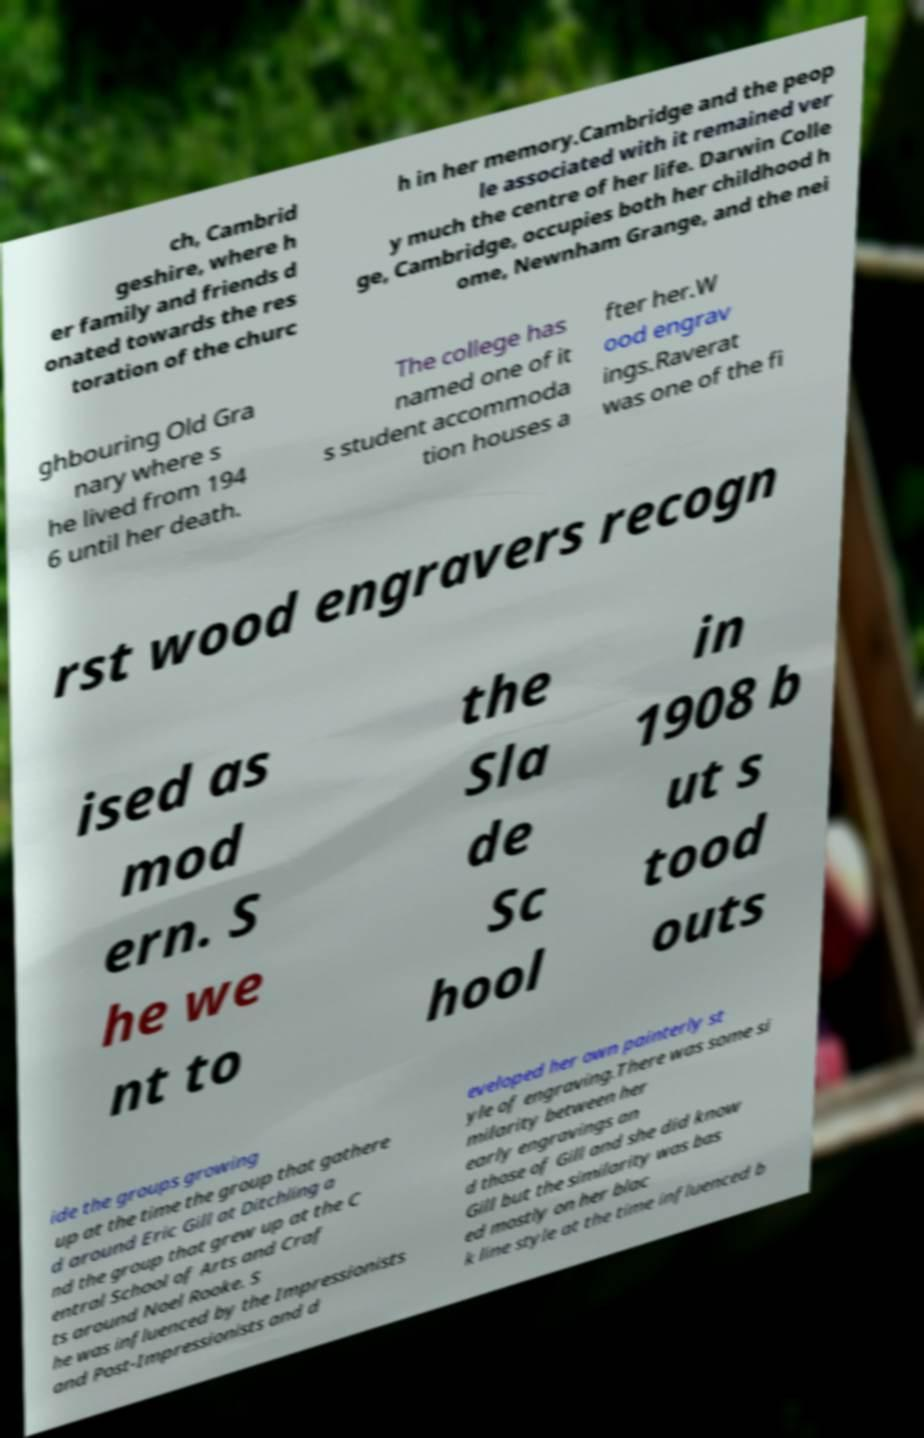Could you assist in decoding the text presented in this image and type it out clearly? ch, Cambrid geshire, where h er family and friends d onated towards the res toration of the churc h in her memory.Cambridge and the peop le associated with it remained ver y much the centre of her life. Darwin Colle ge, Cambridge, occupies both her childhood h ome, Newnham Grange, and the nei ghbouring Old Gra nary where s he lived from 194 6 until her death. The college has named one of it s student accommoda tion houses a fter her.W ood engrav ings.Raverat was one of the fi rst wood engravers recogn ised as mod ern. S he we nt to the Sla de Sc hool in 1908 b ut s tood outs ide the groups growing up at the time the group that gathere d around Eric Gill at Ditchling a nd the group that grew up at the C entral School of Arts and Craf ts around Noel Rooke. S he was influenced by the Impressionists and Post-Impressionists and d eveloped her own painterly st yle of engraving.There was some si milarity between her early engravings an d those of Gill and she did know Gill but the similarity was bas ed mostly on her blac k line style at the time influenced b 